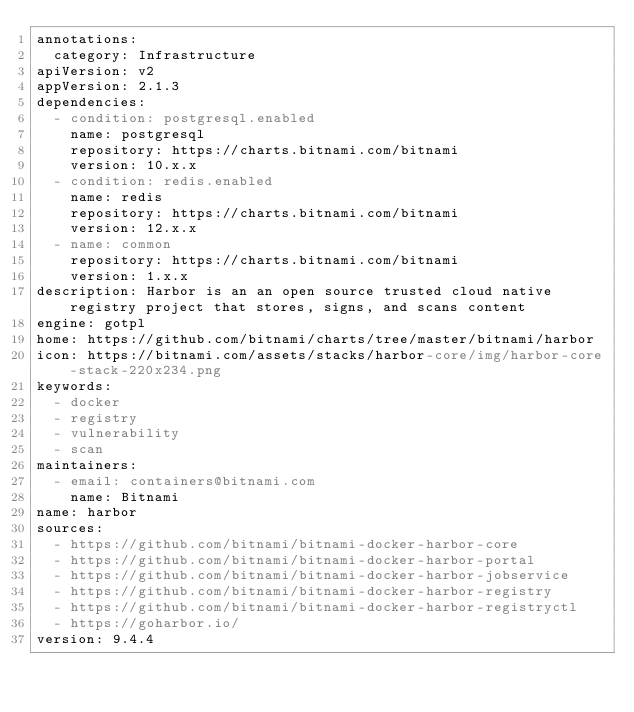<code> <loc_0><loc_0><loc_500><loc_500><_YAML_>annotations:
  category: Infrastructure
apiVersion: v2
appVersion: 2.1.3
dependencies:
  - condition: postgresql.enabled
    name: postgresql
    repository: https://charts.bitnami.com/bitnami
    version: 10.x.x
  - condition: redis.enabled
    name: redis
    repository: https://charts.bitnami.com/bitnami
    version: 12.x.x
  - name: common
    repository: https://charts.bitnami.com/bitnami
    version: 1.x.x
description: Harbor is an an open source trusted cloud native registry project that stores, signs, and scans content
engine: gotpl
home: https://github.com/bitnami/charts/tree/master/bitnami/harbor
icon: https://bitnami.com/assets/stacks/harbor-core/img/harbor-core-stack-220x234.png
keywords:
  - docker
  - registry
  - vulnerability
  - scan
maintainers:
  - email: containers@bitnami.com
    name: Bitnami
name: harbor
sources:
  - https://github.com/bitnami/bitnami-docker-harbor-core
  - https://github.com/bitnami/bitnami-docker-harbor-portal
  - https://github.com/bitnami/bitnami-docker-harbor-jobservice
  - https://github.com/bitnami/bitnami-docker-harbor-registry
  - https://github.com/bitnami/bitnami-docker-harbor-registryctl
  - https://goharbor.io/
version: 9.4.4
</code> 